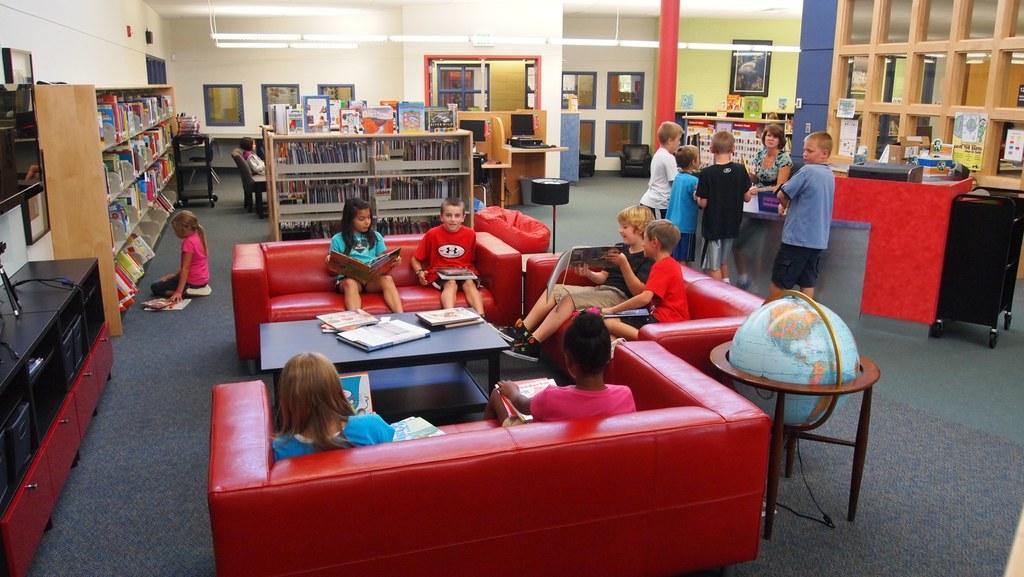In one or two sentences, can you explain what this image depicts? In this image, there is an inside view of a library. There are some kids in the center of the image sitting on couches in front of the table. There are some kids in the top right of the image wearing clothes and standing in front of the another person. There are some racks contains books in the top left of the image. There are some light at the top. 